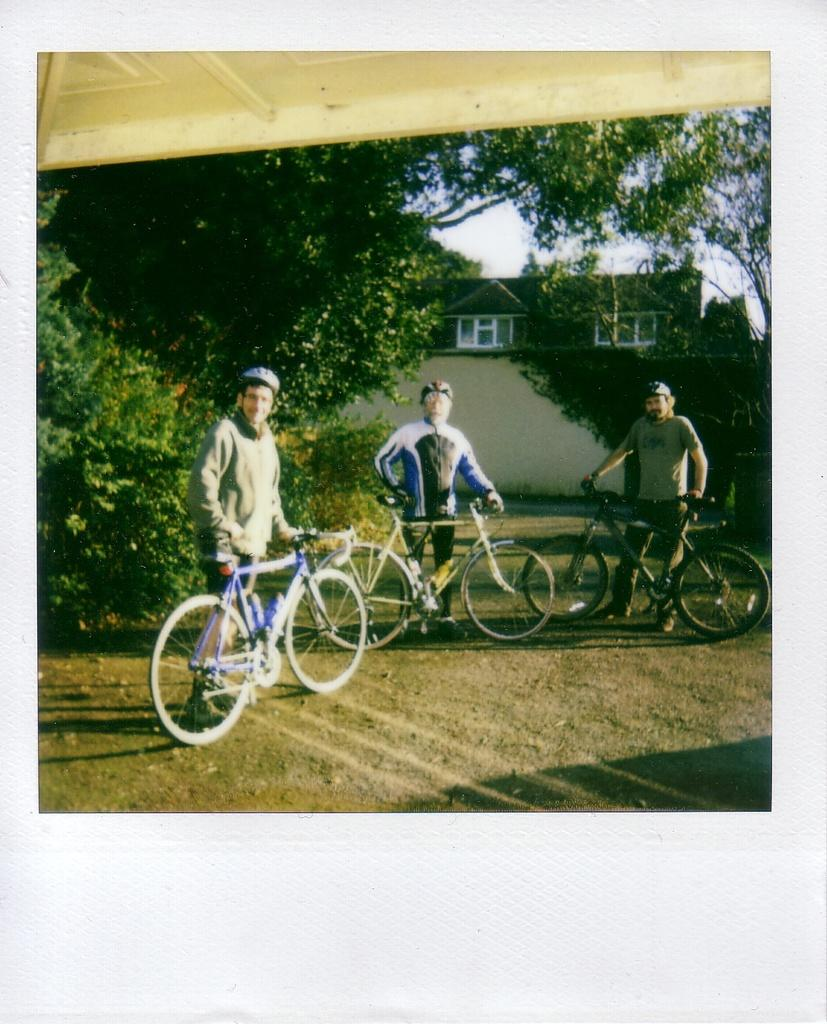How many people are in the image? There are three people in the image. What are the people doing in the image? The people are standing near three bicycles. What type of terrain is visible in the image? There is grass visible in the image. What can be seen in the background of the image? There is a building, trees, and the sky visible in the background of the image. What is the color of the roof in the image? The top of the image has a white-colored roof. What type of bean is growing on the roof in the image? There are no beans present in the image, and the roof is white-colored, not a suitable environment for bean growth. 